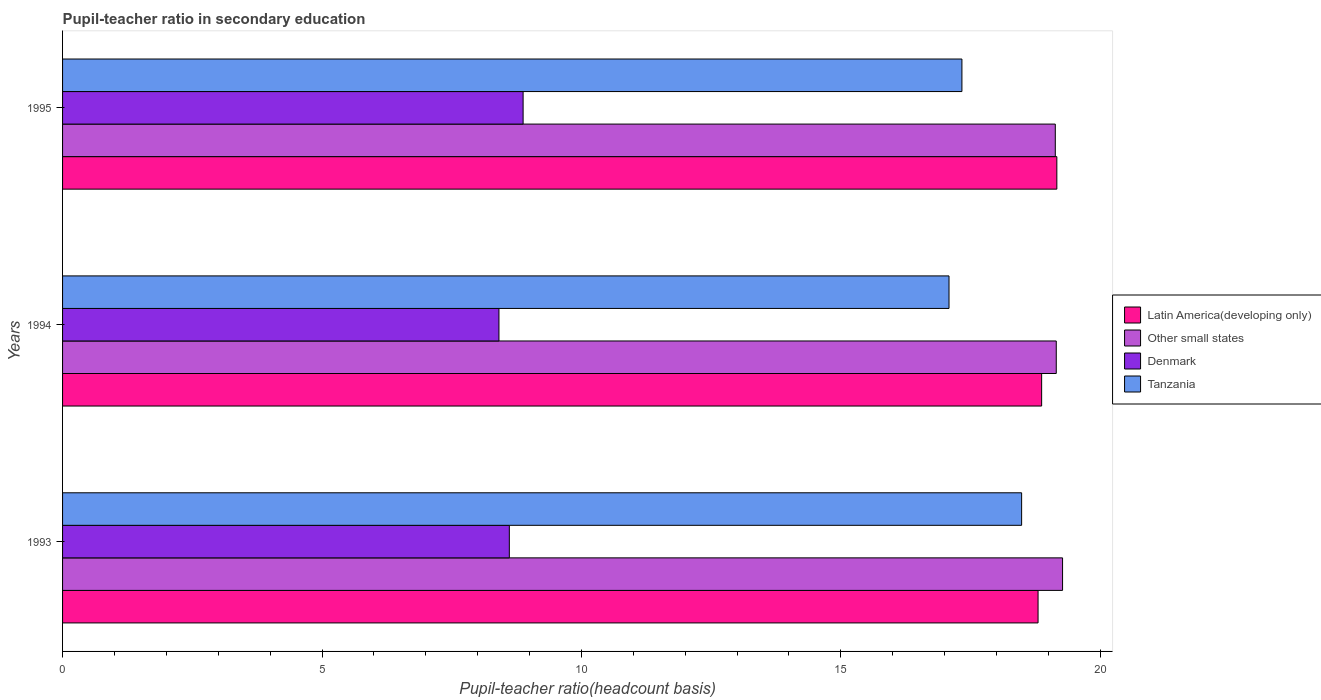Are the number of bars per tick equal to the number of legend labels?
Provide a short and direct response. Yes. Are the number of bars on each tick of the Y-axis equal?
Your response must be concise. Yes. How many bars are there on the 2nd tick from the top?
Ensure brevity in your answer.  4. How many bars are there on the 3rd tick from the bottom?
Ensure brevity in your answer.  4. What is the label of the 3rd group of bars from the top?
Your answer should be compact. 1993. What is the pupil-teacher ratio in secondary education in Other small states in 1993?
Provide a succinct answer. 19.27. Across all years, what is the maximum pupil-teacher ratio in secondary education in Tanzania?
Your answer should be very brief. 18.48. Across all years, what is the minimum pupil-teacher ratio in secondary education in Latin America(developing only)?
Your answer should be compact. 18.8. In which year was the pupil-teacher ratio in secondary education in Latin America(developing only) maximum?
Provide a succinct answer. 1995. What is the total pupil-teacher ratio in secondary education in Tanzania in the graph?
Your response must be concise. 52.9. What is the difference between the pupil-teacher ratio in secondary education in Denmark in 1993 and that in 1994?
Offer a terse response. 0.2. What is the difference between the pupil-teacher ratio in secondary education in Tanzania in 1994 and the pupil-teacher ratio in secondary education in Latin America(developing only) in 1995?
Give a very brief answer. -2.08. What is the average pupil-teacher ratio in secondary education in Latin America(developing only) per year?
Make the answer very short. 18.94. In the year 1993, what is the difference between the pupil-teacher ratio in secondary education in Tanzania and pupil-teacher ratio in secondary education in Other small states?
Your response must be concise. -0.79. In how many years, is the pupil-teacher ratio in secondary education in Other small states greater than 19 ?
Make the answer very short. 3. What is the ratio of the pupil-teacher ratio in secondary education in Latin America(developing only) in 1993 to that in 1994?
Provide a short and direct response. 1. Is the pupil-teacher ratio in secondary education in Latin America(developing only) in 1994 less than that in 1995?
Provide a succinct answer. Yes. What is the difference between the highest and the second highest pupil-teacher ratio in secondary education in Tanzania?
Provide a short and direct response. 1.15. What is the difference between the highest and the lowest pupil-teacher ratio in secondary education in Denmark?
Offer a very short reply. 0.47. What does the 2nd bar from the top in 1995 represents?
Offer a terse response. Denmark. Is it the case that in every year, the sum of the pupil-teacher ratio in secondary education in Tanzania and pupil-teacher ratio in secondary education in Other small states is greater than the pupil-teacher ratio in secondary education in Latin America(developing only)?
Your answer should be very brief. Yes. How many bars are there?
Your answer should be compact. 12. What is the difference between two consecutive major ticks on the X-axis?
Give a very brief answer. 5. How many legend labels are there?
Your answer should be very brief. 4. How are the legend labels stacked?
Your answer should be compact. Vertical. What is the title of the graph?
Your answer should be very brief. Pupil-teacher ratio in secondary education. What is the label or title of the X-axis?
Offer a terse response. Pupil-teacher ratio(headcount basis). What is the label or title of the Y-axis?
Provide a succinct answer. Years. What is the Pupil-teacher ratio(headcount basis) in Latin America(developing only) in 1993?
Your answer should be compact. 18.8. What is the Pupil-teacher ratio(headcount basis) in Other small states in 1993?
Your response must be concise. 19.27. What is the Pupil-teacher ratio(headcount basis) in Denmark in 1993?
Offer a terse response. 8.61. What is the Pupil-teacher ratio(headcount basis) in Tanzania in 1993?
Keep it short and to the point. 18.48. What is the Pupil-teacher ratio(headcount basis) of Latin America(developing only) in 1994?
Give a very brief answer. 18.87. What is the Pupil-teacher ratio(headcount basis) in Other small states in 1994?
Make the answer very short. 19.15. What is the Pupil-teacher ratio(headcount basis) of Denmark in 1994?
Provide a short and direct response. 8.41. What is the Pupil-teacher ratio(headcount basis) of Tanzania in 1994?
Keep it short and to the point. 17.08. What is the Pupil-teacher ratio(headcount basis) of Latin America(developing only) in 1995?
Your answer should be very brief. 19.16. What is the Pupil-teacher ratio(headcount basis) of Other small states in 1995?
Your response must be concise. 19.13. What is the Pupil-teacher ratio(headcount basis) of Denmark in 1995?
Provide a succinct answer. 8.88. What is the Pupil-teacher ratio(headcount basis) of Tanzania in 1995?
Give a very brief answer. 17.33. Across all years, what is the maximum Pupil-teacher ratio(headcount basis) of Latin America(developing only)?
Offer a very short reply. 19.16. Across all years, what is the maximum Pupil-teacher ratio(headcount basis) in Other small states?
Your answer should be very brief. 19.27. Across all years, what is the maximum Pupil-teacher ratio(headcount basis) of Denmark?
Offer a very short reply. 8.88. Across all years, what is the maximum Pupil-teacher ratio(headcount basis) in Tanzania?
Make the answer very short. 18.48. Across all years, what is the minimum Pupil-teacher ratio(headcount basis) in Latin America(developing only)?
Ensure brevity in your answer.  18.8. Across all years, what is the minimum Pupil-teacher ratio(headcount basis) of Other small states?
Your answer should be very brief. 19.13. Across all years, what is the minimum Pupil-teacher ratio(headcount basis) in Denmark?
Give a very brief answer. 8.41. Across all years, what is the minimum Pupil-teacher ratio(headcount basis) of Tanzania?
Keep it short and to the point. 17.08. What is the total Pupil-teacher ratio(headcount basis) in Latin America(developing only) in the graph?
Keep it short and to the point. 56.83. What is the total Pupil-teacher ratio(headcount basis) in Other small states in the graph?
Your response must be concise. 57.56. What is the total Pupil-teacher ratio(headcount basis) of Denmark in the graph?
Offer a terse response. 25.9. What is the total Pupil-teacher ratio(headcount basis) of Tanzania in the graph?
Offer a very short reply. 52.9. What is the difference between the Pupil-teacher ratio(headcount basis) of Latin America(developing only) in 1993 and that in 1994?
Offer a terse response. -0.07. What is the difference between the Pupil-teacher ratio(headcount basis) of Other small states in 1993 and that in 1994?
Your response must be concise. 0.12. What is the difference between the Pupil-teacher ratio(headcount basis) of Tanzania in 1993 and that in 1994?
Make the answer very short. 1.4. What is the difference between the Pupil-teacher ratio(headcount basis) in Latin America(developing only) in 1993 and that in 1995?
Your answer should be very brief. -0.36. What is the difference between the Pupil-teacher ratio(headcount basis) of Other small states in 1993 and that in 1995?
Give a very brief answer. 0.14. What is the difference between the Pupil-teacher ratio(headcount basis) of Denmark in 1993 and that in 1995?
Provide a succinct answer. -0.27. What is the difference between the Pupil-teacher ratio(headcount basis) of Tanzania in 1993 and that in 1995?
Make the answer very short. 1.15. What is the difference between the Pupil-teacher ratio(headcount basis) of Latin America(developing only) in 1994 and that in 1995?
Offer a very short reply. -0.29. What is the difference between the Pupil-teacher ratio(headcount basis) of Other small states in 1994 and that in 1995?
Provide a short and direct response. 0.02. What is the difference between the Pupil-teacher ratio(headcount basis) of Denmark in 1994 and that in 1995?
Provide a short and direct response. -0.47. What is the difference between the Pupil-teacher ratio(headcount basis) of Tanzania in 1994 and that in 1995?
Make the answer very short. -0.25. What is the difference between the Pupil-teacher ratio(headcount basis) of Latin America(developing only) in 1993 and the Pupil-teacher ratio(headcount basis) of Other small states in 1994?
Your response must be concise. -0.35. What is the difference between the Pupil-teacher ratio(headcount basis) of Latin America(developing only) in 1993 and the Pupil-teacher ratio(headcount basis) of Denmark in 1994?
Your answer should be very brief. 10.39. What is the difference between the Pupil-teacher ratio(headcount basis) of Latin America(developing only) in 1993 and the Pupil-teacher ratio(headcount basis) of Tanzania in 1994?
Keep it short and to the point. 1.72. What is the difference between the Pupil-teacher ratio(headcount basis) in Other small states in 1993 and the Pupil-teacher ratio(headcount basis) in Denmark in 1994?
Provide a short and direct response. 10.86. What is the difference between the Pupil-teacher ratio(headcount basis) in Other small states in 1993 and the Pupil-teacher ratio(headcount basis) in Tanzania in 1994?
Your response must be concise. 2.19. What is the difference between the Pupil-teacher ratio(headcount basis) of Denmark in 1993 and the Pupil-teacher ratio(headcount basis) of Tanzania in 1994?
Offer a very short reply. -8.47. What is the difference between the Pupil-teacher ratio(headcount basis) of Latin America(developing only) in 1993 and the Pupil-teacher ratio(headcount basis) of Other small states in 1995?
Keep it short and to the point. -0.33. What is the difference between the Pupil-teacher ratio(headcount basis) in Latin America(developing only) in 1993 and the Pupil-teacher ratio(headcount basis) in Denmark in 1995?
Provide a short and direct response. 9.92. What is the difference between the Pupil-teacher ratio(headcount basis) of Latin America(developing only) in 1993 and the Pupil-teacher ratio(headcount basis) of Tanzania in 1995?
Make the answer very short. 1.47. What is the difference between the Pupil-teacher ratio(headcount basis) of Other small states in 1993 and the Pupil-teacher ratio(headcount basis) of Denmark in 1995?
Offer a very short reply. 10.4. What is the difference between the Pupil-teacher ratio(headcount basis) of Other small states in 1993 and the Pupil-teacher ratio(headcount basis) of Tanzania in 1995?
Keep it short and to the point. 1.94. What is the difference between the Pupil-teacher ratio(headcount basis) in Denmark in 1993 and the Pupil-teacher ratio(headcount basis) in Tanzania in 1995?
Provide a short and direct response. -8.72. What is the difference between the Pupil-teacher ratio(headcount basis) of Latin America(developing only) in 1994 and the Pupil-teacher ratio(headcount basis) of Other small states in 1995?
Your answer should be compact. -0.26. What is the difference between the Pupil-teacher ratio(headcount basis) of Latin America(developing only) in 1994 and the Pupil-teacher ratio(headcount basis) of Denmark in 1995?
Your answer should be very brief. 9.99. What is the difference between the Pupil-teacher ratio(headcount basis) in Latin America(developing only) in 1994 and the Pupil-teacher ratio(headcount basis) in Tanzania in 1995?
Give a very brief answer. 1.54. What is the difference between the Pupil-teacher ratio(headcount basis) of Other small states in 1994 and the Pupil-teacher ratio(headcount basis) of Denmark in 1995?
Your response must be concise. 10.28. What is the difference between the Pupil-teacher ratio(headcount basis) of Other small states in 1994 and the Pupil-teacher ratio(headcount basis) of Tanzania in 1995?
Offer a very short reply. 1.82. What is the difference between the Pupil-teacher ratio(headcount basis) in Denmark in 1994 and the Pupil-teacher ratio(headcount basis) in Tanzania in 1995?
Your answer should be very brief. -8.92. What is the average Pupil-teacher ratio(headcount basis) in Latin America(developing only) per year?
Offer a very short reply. 18.94. What is the average Pupil-teacher ratio(headcount basis) in Other small states per year?
Offer a very short reply. 19.19. What is the average Pupil-teacher ratio(headcount basis) of Denmark per year?
Offer a terse response. 8.63. What is the average Pupil-teacher ratio(headcount basis) of Tanzania per year?
Ensure brevity in your answer.  17.63. In the year 1993, what is the difference between the Pupil-teacher ratio(headcount basis) in Latin America(developing only) and Pupil-teacher ratio(headcount basis) in Other small states?
Keep it short and to the point. -0.47. In the year 1993, what is the difference between the Pupil-teacher ratio(headcount basis) in Latin America(developing only) and Pupil-teacher ratio(headcount basis) in Denmark?
Give a very brief answer. 10.19. In the year 1993, what is the difference between the Pupil-teacher ratio(headcount basis) of Latin America(developing only) and Pupil-teacher ratio(headcount basis) of Tanzania?
Provide a short and direct response. 0.32. In the year 1993, what is the difference between the Pupil-teacher ratio(headcount basis) in Other small states and Pupil-teacher ratio(headcount basis) in Denmark?
Give a very brief answer. 10.66. In the year 1993, what is the difference between the Pupil-teacher ratio(headcount basis) of Other small states and Pupil-teacher ratio(headcount basis) of Tanzania?
Offer a terse response. 0.79. In the year 1993, what is the difference between the Pupil-teacher ratio(headcount basis) in Denmark and Pupil-teacher ratio(headcount basis) in Tanzania?
Keep it short and to the point. -9.87. In the year 1994, what is the difference between the Pupil-teacher ratio(headcount basis) of Latin America(developing only) and Pupil-teacher ratio(headcount basis) of Other small states?
Ensure brevity in your answer.  -0.28. In the year 1994, what is the difference between the Pupil-teacher ratio(headcount basis) of Latin America(developing only) and Pupil-teacher ratio(headcount basis) of Denmark?
Your answer should be very brief. 10.46. In the year 1994, what is the difference between the Pupil-teacher ratio(headcount basis) in Latin America(developing only) and Pupil-teacher ratio(headcount basis) in Tanzania?
Offer a very short reply. 1.78. In the year 1994, what is the difference between the Pupil-teacher ratio(headcount basis) in Other small states and Pupil-teacher ratio(headcount basis) in Denmark?
Keep it short and to the point. 10.74. In the year 1994, what is the difference between the Pupil-teacher ratio(headcount basis) of Other small states and Pupil-teacher ratio(headcount basis) of Tanzania?
Provide a succinct answer. 2.07. In the year 1994, what is the difference between the Pupil-teacher ratio(headcount basis) in Denmark and Pupil-teacher ratio(headcount basis) in Tanzania?
Offer a terse response. -8.67. In the year 1995, what is the difference between the Pupil-teacher ratio(headcount basis) of Latin America(developing only) and Pupil-teacher ratio(headcount basis) of Other small states?
Provide a short and direct response. 0.03. In the year 1995, what is the difference between the Pupil-teacher ratio(headcount basis) in Latin America(developing only) and Pupil-teacher ratio(headcount basis) in Denmark?
Offer a very short reply. 10.29. In the year 1995, what is the difference between the Pupil-teacher ratio(headcount basis) of Latin America(developing only) and Pupil-teacher ratio(headcount basis) of Tanzania?
Your response must be concise. 1.83. In the year 1995, what is the difference between the Pupil-teacher ratio(headcount basis) in Other small states and Pupil-teacher ratio(headcount basis) in Denmark?
Your answer should be compact. 10.26. In the year 1995, what is the difference between the Pupil-teacher ratio(headcount basis) in Other small states and Pupil-teacher ratio(headcount basis) in Tanzania?
Offer a very short reply. 1.8. In the year 1995, what is the difference between the Pupil-teacher ratio(headcount basis) of Denmark and Pupil-teacher ratio(headcount basis) of Tanzania?
Your response must be concise. -8.46. What is the ratio of the Pupil-teacher ratio(headcount basis) of Latin America(developing only) in 1993 to that in 1994?
Provide a short and direct response. 1. What is the ratio of the Pupil-teacher ratio(headcount basis) in Denmark in 1993 to that in 1994?
Your answer should be compact. 1.02. What is the ratio of the Pupil-teacher ratio(headcount basis) in Tanzania in 1993 to that in 1994?
Your response must be concise. 1.08. What is the ratio of the Pupil-teacher ratio(headcount basis) of Latin America(developing only) in 1993 to that in 1995?
Ensure brevity in your answer.  0.98. What is the ratio of the Pupil-teacher ratio(headcount basis) of Other small states in 1993 to that in 1995?
Offer a very short reply. 1.01. What is the ratio of the Pupil-teacher ratio(headcount basis) of Denmark in 1993 to that in 1995?
Keep it short and to the point. 0.97. What is the ratio of the Pupil-teacher ratio(headcount basis) of Tanzania in 1993 to that in 1995?
Your response must be concise. 1.07. What is the ratio of the Pupil-teacher ratio(headcount basis) of Latin America(developing only) in 1994 to that in 1995?
Offer a very short reply. 0.98. What is the ratio of the Pupil-teacher ratio(headcount basis) in Other small states in 1994 to that in 1995?
Make the answer very short. 1. What is the ratio of the Pupil-teacher ratio(headcount basis) in Denmark in 1994 to that in 1995?
Make the answer very short. 0.95. What is the ratio of the Pupil-teacher ratio(headcount basis) in Tanzania in 1994 to that in 1995?
Your answer should be very brief. 0.99. What is the difference between the highest and the second highest Pupil-teacher ratio(headcount basis) in Latin America(developing only)?
Keep it short and to the point. 0.29. What is the difference between the highest and the second highest Pupil-teacher ratio(headcount basis) in Other small states?
Ensure brevity in your answer.  0.12. What is the difference between the highest and the second highest Pupil-teacher ratio(headcount basis) in Denmark?
Give a very brief answer. 0.27. What is the difference between the highest and the second highest Pupil-teacher ratio(headcount basis) in Tanzania?
Provide a succinct answer. 1.15. What is the difference between the highest and the lowest Pupil-teacher ratio(headcount basis) in Latin America(developing only)?
Your response must be concise. 0.36. What is the difference between the highest and the lowest Pupil-teacher ratio(headcount basis) in Other small states?
Keep it short and to the point. 0.14. What is the difference between the highest and the lowest Pupil-teacher ratio(headcount basis) of Denmark?
Keep it short and to the point. 0.47. What is the difference between the highest and the lowest Pupil-teacher ratio(headcount basis) of Tanzania?
Your response must be concise. 1.4. 